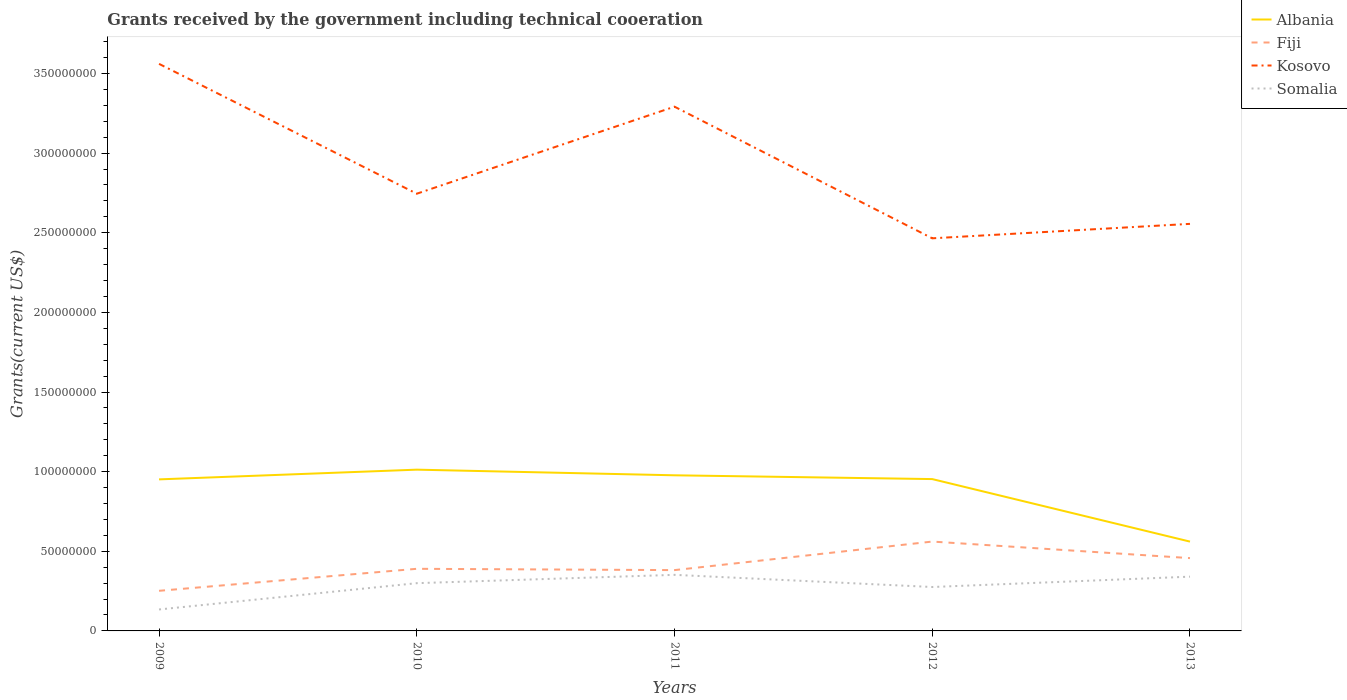How many different coloured lines are there?
Make the answer very short. 4. Is the number of lines equal to the number of legend labels?
Provide a short and direct response. Yes. Across all years, what is the maximum total grants received by the government in Kosovo?
Give a very brief answer. 2.46e+08. What is the total total grants received by the government in Albania in the graph?
Make the answer very short. -1.80e+05. What is the difference between the highest and the second highest total grants received by the government in Kosovo?
Provide a succinct answer. 1.10e+08. What is the difference between the highest and the lowest total grants received by the government in Somalia?
Keep it short and to the point. 3. What is the difference between two consecutive major ticks on the Y-axis?
Offer a terse response. 5.00e+07. Are the values on the major ticks of Y-axis written in scientific E-notation?
Offer a terse response. No. Does the graph contain any zero values?
Provide a short and direct response. No. How are the legend labels stacked?
Provide a succinct answer. Vertical. What is the title of the graph?
Provide a succinct answer. Grants received by the government including technical cooeration. What is the label or title of the X-axis?
Offer a terse response. Years. What is the label or title of the Y-axis?
Keep it short and to the point. Grants(current US$). What is the Grants(current US$) of Albania in 2009?
Offer a very short reply. 9.52e+07. What is the Grants(current US$) of Fiji in 2009?
Give a very brief answer. 2.52e+07. What is the Grants(current US$) in Kosovo in 2009?
Ensure brevity in your answer.  3.56e+08. What is the Grants(current US$) of Somalia in 2009?
Keep it short and to the point. 1.35e+07. What is the Grants(current US$) of Albania in 2010?
Keep it short and to the point. 1.01e+08. What is the Grants(current US$) of Fiji in 2010?
Offer a terse response. 3.90e+07. What is the Grants(current US$) of Kosovo in 2010?
Keep it short and to the point. 2.74e+08. What is the Grants(current US$) of Somalia in 2010?
Provide a succinct answer. 3.00e+07. What is the Grants(current US$) of Albania in 2011?
Your response must be concise. 9.77e+07. What is the Grants(current US$) of Fiji in 2011?
Your answer should be compact. 3.82e+07. What is the Grants(current US$) in Kosovo in 2011?
Offer a very short reply. 3.29e+08. What is the Grants(current US$) of Somalia in 2011?
Offer a very short reply. 3.52e+07. What is the Grants(current US$) in Albania in 2012?
Offer a very short reply. 9.53e+07. What is the Grants(current US$) in Fiji in 2012?
Give a very brief answer. 5.61e+07. What is the Grants(current US$) of Kosovo in 2012?
Give a very brief answer. 2.46e+08. What is the Grants(current US$) in Somalia in 2012?
Give a very brief answer. 2.76e+07. What is the Grants(current US$) in Albania in 2013?
Give a very brief answer. 5.61e+07. What is the Grants(current US$) in Fiji in 2013?
Offer a very short reply. 4.57e+07. What is the Grants(current US$) of Kosovo in 2013?
Your answer should be compact. 2.56e+08. What is the Grants(current US$) in Somalia in 2013?
Your response must be concise. 3.41e+07. Across all years, what is the maximum Grants(current US$) in Albania?
Make the answer very short. 1.01e+08. Across all years, what is the maximum Grants(current US$) in Fiji?
Offer a very short reply. 5.61e+07. Across all years, what is the maximum Grants(current US$) of Kosovo?
Give a very brief answer. 3.56e+08. Across all years, what is the maximum Grants(current US$) of Somalia?
Your answer should be very brief. 3.52e+07. Across all years, what is the minimum Grants(current US$) in Albania?
Provide a succinct answer. 5.61e+07. Across all years, what is the minimum Grants(current US$) in Fiji?
Provide a short and direct response. 2.52e+07. Across all years, what is the minimum Grants(current US$) of Kosovo?
Keep it short and to the point. 2.46e+08. Across all years, what is the minimum Grants(current US$) in Somalia?
Your response must be concise. 1.35e+07. What is the total Grants(current US$) in Albania in the graph?
Your answer should be very brief. 4.46e+08. What is the total Grants(current US$) of Fiji in the graph?
Give a very brief answer. 2.04e+08. What is the total Grants(current US$) of Kosovo in the graph?
Provide a succinct answer. 1.46e+09. What is the total Grants(current US$) of Somalia in the graph?
Give a very brief answer. 1.40e+08. What is the difference between the Grants(current US$) of Albania in 2009 and that in 2010?
Provide a succinct answer. -6.10e+06. What is the difference between the Grants(current US$) in Fiji in 2009 and that in 2010?
Offer a very short reply. -1.38e+07. What is the difference between the Grants(current US$) in Kosovo in 2009 and that in 2010?
Provide a succinct answer. 8.15e+07. What is the difference between the Grants(current US$) of Somalia in 2009 and that in 2010?
Keep it short and to the point. -1.65e+07. What is the difference between the Grants(current US$) of Albania in 2009 and that in 2011?
Your response must be concise. -2.56e+06. What is the difference between the Grants(current US$) in Fiji in 2009 and that in 2011?
Your response must be concise. -1.30e+07. What is the difference between the Grants(current US$) in Kosovo in 2009 and that in 2011?
Provide a succinct answer. 2.69e+07. What is the difference between the Grants(current US$) in Somalia in 2009 and that in 2011?
Offer a very short reply. -2.17e+07. What is the difference between the Grants(current US$) of Albania in 2009 and that in 2012?
Make the answer very short. -1.80e+05. What is the difference between the Grants(current US$) of Fiji in 2009 and that in 2012?
Provide a short and direct response. -3.09e+07. What is the difference between the Grants(current US$) in Kosovo in 2009 and that in 2012?
Provide a short and direct response. 1.10e+08. What is the difference between the Grants(current US$) of Somalia in 2009 and that in 2012?
Provide a short and direct response. -1.41e+07. What is the difference between the Grants(current US$) of Albania in 2009 and that in 2013?
Your response must be concise. 3.91e+07. What is the difference between the Grants(current US$) of Fiji in 2009 and that in 2013?
Provide a succinct answer. -2.05e+07. What is the difference between the Grants(current US$) in Kosovo in 2009 and that in 2013?
Offer a terse response. 1.00e+08. What is the difference between the Grants(current US$) of Somalia in 2009 and that in 2013?
Keep it short and to the point. -2.06e+07. What is the difference between the Grants(current US$) in Albania in 2010 and that in 2011?
Make the answer very short. 3.54e+06. What is the difference between the Grants(current US$) of Fiji in 2010 and that in 2011?
Your answer should be compact. 8.20e+05. What is the difference between the Grants(current US$) of Kosovo in 2010 and that in 2011?
Provide a succinct answer. -5.46e+07. What is the difference between the Grants(current US$) of Somalia in 2010 and that in 2011?
Your response must be concise. -5.23e+06. What is the difference between the Grants(current US$) of Albania in 2010 and that in 2012?
Your response must be concise. 5.92e+06. What is the difference between the Grants(current US$) in Fiji in 2010 and that in 2012?
Your answer should be compact. -1.71e+07. What is the difference between the Grants(current US$) of Kosovo in 2010 and that in 2012?
Make the answer very short. 2.80e+07. What is the difference between the Grants(current US$) in Somalia in 2010 and that in 2012?
Provide a short and direct response. 2.41e+06. What is the difference between the Grants(current US$) of Albania in 2010 and that in 2013?
Keep it short and to the point. 4.52e+07. What is the difference between the Grants(current US$) of Fiji in 2010 and that in 2013?
Your answer should be very brief. -6.71e+06. What is the difference between the Grants(current US$) of Kosovo in 2010 and that in 2013?
Make the answer very short. 1.89e+07. What is the difference between the Grants(current US$) of Somalia in 2010 and that in 2013?
Keep it short and to the point. -4.09e+06. What is the difference between the Grants(current US$) of Albania in 2011 and that in 2012?
Your response must be concise. 2.38e+06. What is the difference between the Grants(current US$) in Fiji in 2011 and that in 2012?
Keep it short and to the point. -1.79e+07. What is the difference between the Grants(current US$) in Kosovo in 2011 and that in 2012?
Provide a short and direct response. 8.26e+07. What is the difference between the Grants(current US$) in Somalia in 2011 and that in 2012?
Keep it short and to the point. 7.64e+06. What is the difference between the Grants(current US$) in Albania in 2011 and that in 2013?
Provide a short and direct response. 4.16e+07. What is the difference between the Grants(current US$) in Fiji in 2011 and that in 2013?
Provide a short and direct response. -7.53e+06. What is the difference between the Grants(current US$) of Kosovo in 2011 and that in 2013?
Your answer should be compact. 7.36e+07. What is the difference between the Grants(current US$) in Somalia in 2011 and that in 2013?
Provide a succinct answer. 1.14e+06. What is the difference between the Grants(current US$) in Albania in 2012 and that in 2013?
Make the answer very short. 3.92e+07. What is the difference between the Grants(current US$) in Fiji in 2012 and that in 2013?
Provide a succinct answer. 1.04e+07. What is the difference between the Grants(current US$) of Kosovo in 2012 and that in 2013?
Provide a short and direct response. -9.07e+06. What is the difference between the Grants(current US$) of Somalia in 2012 and that in 2013?
Keep it short and to the point. -6.50e+06. What is the difference between the Grants(current US$) in Albania in 2009 and the Grants(current US$) in Fiji in 2010?
Your response must be concise. 5.62e+07. What is the difference between the Grants(current US$) of Albania in 2009 and the Grants(current US$) of Kosovo in 2010?
Provide a succinct answer. -1.79e+08. What is the difference between the Grants(current US$) in Albania in 2009 and the Grants(current US$) in Somalia in 2010?
Your response must be concise. 6.52e+07. What is the difference between the Grants(current US$) in Fiji in 2009 and the Grants(current US$) in Kosovo in 2010?
Your answer should be very brief. -2.49e+08. What is the difference between the Grants(current US$) in Fiji in 2009 and the Grants(current US$) in Somalia in 2010?
Provide a succinct answer. -4.80e+06. What is the difference between the Grants(current US$) in Kosovo in 2009 and the Grants(current US$) in Somalia in 2010?
Offer a very short reply. 3.26e+08. What is the difference between the Grants(current US$) in Albania in 2009 and the Grants(current US$) in Fiji in 2011?
Make the answer very short. 5.70e+07. What is the difference between the Grants(current US$) of Albania in 2009 and the Grants(current US$) of Kosovo in 2011?
Make the answer very short. -2.34e+08. What is the difference between the Grants(current US$) of Albania in 2009 and the Grants(current US$) of Somalia in 2011?
Your answer should be compact. 5.99e+07. What is the difference between the Grants(current US$) of Fiji in 2009 and the Grants(current US$) of Kosovo in 2011?
Your answer should be compact. -3.04e+08. What is the difference between the Grants(current US$) in Fiji in 2009 and the Grants(current US$) in Somalia in 2011?
Provide a short and direct response. -1.00e+07. What is the difference between the Grants(current US$) in Kosovo in 2009 and the Grants(current US$) in Somalia in 2011?
Your answer should be compact. 3.21e+08. What is the difference between the Grants(current US$) of Albania in 2009 and the Grants(current US$) of Fiji in 2012?
Your answer should be compact. 3.90e+07. What is the difference between the Grants(current US$) in Albania in 2009 and the Grants(current US$) in Kosovo in 2012?
Offer a very short reply. -1.51e+08. What is the difference between the Grants(current US$) of Albania in 2009 and the Grants(current US$) of Somalia in 2012?
Provide a short and direct response. 6.76e+07. What is the difference between the Grants(current US$) in Fiji in 2009 and the Grants(current US$) in Kosovo in 2012?
Provide a short and direct response. -2.21e+08. What is the difference between the Grants(current US$) of Fiji in 2009 and the Grants(current US$) of Somalia in 2012?
Your response must be concise. -2.39e+06. What is the difference between the Grants(current US$) of Kosovo in 2009 and the Grants(current US$) of Somalia in 2012?
Offer a terse response. 3.28e+08. What is the difference between the Grants(current US$) in Albania in 2009 and the Grants(current US$) in Fiji in 2013?
Offer a very short reply. 4.94e+07. What is the difference between the Grants(current US$) of Albania in 2009 and the Grants(current US$) of Kosovo in 2013?
Your answer should be compact. -1.60e+08. What is the difference between the Grants(current US$) in Albania in 2009 and the Grants(current US$) in Somalia in 2013?
Provide a short and direct response. 6.11e+07. What is the difference between the Grants(current US$) of Fiji in 2009 and the Grants(current US$) of Kosovo in 2013?
Ensure brevity in your answer.  -2.30e+08. What is the difference between the Grants(current US$) of Fiji in 2009 and the Grants(current US$) of Somalia in 2013?
Offer a terse response. -8.89e+06. What is the difference between the Grants(current US$) of Kosovo in 2009 and the Grants(current US$) of Somalia in 2013?
Offer a terse response. 3.22e+08. What is the difference between the Grants(current US$) in Albania in 2010 and the Grants(current US$) in Fiji in 2011?
Provide a succinct answer. 6.31e+07. What is the difference between the Grants(current US$) in Albania in 2010 and the Grants(current US$) in Kosovo in 2011?
Provide a succinct answer. -2.28e+08. What is the difference between the Grants(current US$) of Albania in 2010 and the Grants(current US$) of Somalia in 2011?
Provide a short and direct response. 6.60e+07. What is the difference between the Grants(current US$) in Fiji in 2010 and the Grants(current US$) in Kosovo in 2011?
Keep it short and to the point. -2.90e+08. What is the difference between the Grants(current US$) in Fiji in 2010 and the Grants(current US$) in Somalia in 2011?
Provide a succinct answer. 3.79e+06. What is the difference between the Grants(current US$) in Kosovo in 2010 and the Grants(current US$) in Somalia in 2011?
Keep it short and to the point. 2.39e+08. What is the difference between the Grants(current US$) of Albania in 2010 and the Grants(current US$) of Fiji in 2012?
Offer a terse response. 4.52e+07. What is the difference between the Grants(current US$) in Albania in 2010 and the Grants(current US$) in Kosovo in 2012?
Your response must be concise. -1.45e+08. What is the difference between the Grants(current US$) of Albania in 2010 and the Grants(current US$) of Somalia in 2012?
Offer a terse response. 7.37e+07. What is the difference between the Grants(current US$) of Fiji in 2010 and the Grants(current US$) of Kosovo in 2012?
Your response must be concise. -2.08e+08. What is the difference between the Grants(current US$) in Fiji in 2010 and the Grants(current US$) in Somalia in 2012?
Your answer should be compact. 1.14e+07. What is the difference between the Grants(current US$) of Kosovo in 2010 and the Grants(current US$) of Somalia in 2012?
Offer a very short reply. 2.47e+08. What is the difference between the Grants(current US$) in Albania in 2010 and the Grants(current US$) in Fiji in 2013?
Your response must be concise. 5.55e+07. What is the difference between the Grants(current US$) of Albania in 2010 and the Grants(current US$) of Kosovo in 2013?
Offer a terse response. -1.54e+08. What is the difference between the Grants(current US$) of Albania in 2010 and the Grants(current US$) of Somalia in 2013?
Make the answer very short. 6.72e+07. What is the difference between the Grants(current US$) in Fiji in 2010 and the Grants(current US$) in Kosovo in 2013?
Your answer should be very brief. -2.17e+08. What is the difference between the Grants(current US$) of Fiji in 2010 and the Grants(current US$) of Somalia in 2013?
Your answer should be very brief. 4.93e+06. What is the difference between the Grants(current US$) of Kosovo in 2010 and the Grants(current US$) of Somalia in 2013?
Your answer should be compact. 2.40e+08. What is the difference between the Grants(current US$) of Albania in 2011 and the Grants(current US$) of Fiji in 2012?
Ensure brevity in your answer.  4.16e+07. What is the difference between the Grants(current US$) of Albania in 2011 and the Grants(current US$) of Kosovo in 2012?
Make the answer very short. -1.49e+08. What is the difference between the Grants(current US$) in Albania in 2011 and the Grants(current US$) in Somalia in 2012?
Ensure brevity in your answer.  7.01e+07. What is the difference between the Grants(current US$) of Fiji in 2011 and the Grants(current US$) of Kosovo in 2012?
Make the answer very short. -2.08e+08. What is the difference between the Grants(current US$) in Fiji in 2011 and the Grants(current US$) in Somalia in 2012?
Your answer should be compact. 1.06e+07. What is the difference between the Grants(current US$) of Kosovo in 2011 and the Grants(current US$) of Somalia in 2012?
Keep it short and to the point. 3.02e+08. What is the difference between the Grants(current US$) in Albania in 2011 and the Grants(current US$) in Fiji in 2013?
Provide a succinct answer. 5.20e+07. What is the difference between the Grants(current US$) of Albania in 2011 and the Grants(current US$) of Kosovo in 2013?
Make the answer very short. -1.58e+08. What is the difference between the Grants(current US$) in Albania in 2011 and the Grants(current US$) in Somalia in 2013?
Make the answer very short. 6.36e+07. What is the difference between the Grants(current US$) of Fiji in 2011 and the Grants(current US$) of Kosovo in 2013?
Keep it short and to the point. -2.17e+08. What is the difference between the Grants(current US$) of Fiji in 2011 and the Grants(current US$) of Somalia in 2013?
Offer a terse response. 4.11e+06. What is the difference between the Grants(current US$) of Kosovo in 2011 and the Grants(current US$) of Somalia in 2013?
Offer a very short reply. 2.95e+08. What is the difference between the Grants(current US$) of Albania in 2012 and the Grants(current US$) of Fiji in 2013?
Provide a succinct answer. 4.96e+07. What is the difference between the Grants(current US$) of Albania in 2012 and the Grants(current US$) of Kosovo in 2013?
Provide a succinct answer. -1.60e+08. What is the difference between the Grants(current US$) of Albania in 2012 and the Grants(current US$) of Somalia in 2013?
Your answer should be very brief. 6.13e+07. What is the difference between the Grants(current US$) in Fiji in 2012 and the Grants(current US$) in Kosovo in 2013?
Your response must be concise. -1.99e+08. What is the difference between the Grants(current US$) of Fiji in 2012 and the Grants(current US$) of Somalia in 2013?
Give a very brief answer. 2.20e+07. What is the difference between the Grants(current US$) in Kosovo in 2012 and the Grants(current US$) in Somalia in 2013?
Your response must be concise. 2.12e+08. What is the average Grants(current US$) of Albania per year?
Your response must be concise. 8.91e+07. What is the average Grants(current US$) in Fiji per year?
Offer a very short reply. 4.08e+07. What is the average Grants(current US$) of Kosovo per year?
Offer a very short reply. 2.92e+08. What is the average Grants(current US$) of Somalia per year?
Make the answer very short. 2.81e+07. In the year 2009, what is the difference between the Grants(current US$) in Albania and Grants(current US$) in Fiji?
Offer a terse response. 7.00e+07. In the year 2009, what is the difference between the Grants(current US$) in Albania and Grants(current US$) in Kosovo?
Make the answer very short. -2.61e+08. In the year 2009, what is the difference between the Grants(current US$) in Albania and Grants(current US$) in Somalia?
Provide a short and direct response. 8.17e+07. In the year 2009, what is the difference between the Grants(current US$) of Fiji and Grants(current US$) of Kosovo?
Make the answer very short. -3.31e+08. In the year 2009, what is the difference between the Grants(current US$) of Fiji and Grants(current US$) of Somalia?
Provide a succinct answer. 1.17e+07. In the year 2009, what is the difference between the Grants(current US$) of Kosovo and Grants(current US$) of Somalia?
Offer a terse response. 3.43e+08. In the year 2010, what is the difference between the Grants(current US$) of Albania and Grants(current US$) of Fiji?
Keep it short and to the point. 6.22e+07. In the year 2010, what is the difference between the Grants(current US$) of Albania and Grants(current US$) of Kosovo?
Offer a very short reply. -1.73e+08. In the year 2010, what is the difference between the Grants(current US$) in Albania and Grants(current US$) in Somalia?
Your response must be concise. 7.13e+07. In the year 2010, what is the difference between the Grants(current US$) of Fiji and Grants(current US$) of Kosovo?
Offer a very short reply. -2.36e+08. In the year 2010, what is the difference between the Grants(current US$) in Fiji and Grants(current US$) in Somalia?
Your answer should be very brief. 9.02e+06. In the year 2010, what is the difference between the Grants(current US$) of Kosovo and Grants(current US$) of Somalia?
Give a very brief answer. 2.45e+08. In the year 2011, what is the difference between the Grants(current US$) of Albania and Grants(current US$) of Fiji?
Your answer should be very brief. 5.95e+07. In the year 2011, what is the difference between the Grants(current US$) in Albania and Grants(current US$) in Kosovo?
Your answer should be very brief. -2.31e+08. In the year 2011, what is the difference between the Grants(current US$) in Albania and Grants(current US$) in Somalia?
Give a very brief answer. 6.25e+07. In the year 2011, what is the difference between the Grants(current US$) of Fiji and Grants(current US$) of Kosovo?
Your answer should be very brief. -2.91e+08. In the year 2011, what is the difference between the Grants(current US$) in Fiji and Grants(current US$) in Somalia?
Ensure brevity in your answer.  2.97e+06. In the year 2011, what is the difference between the Grants(current US$) of Kosovo and Grants(current US$) of Somalia?
Your response must be concise. 2.94e+08. In the year 2012, what is the difference between the Grants(current US$) in Albania and Grants(current US$) in Fiji?
Ensure brevity in your answer.  3.92e+07. In the year 2012, what is the difference between the Grants(current US$) of Albania and Grants(current US$) of Kosovo?
Your answer should be very brief. -1.51e+08. In the year 2012, what is the difference between the Grants(current US$) in Albania and Grants(current US$) in Somalia?
Make the answer very short. 6.78e+07. In the year 2012, what is the difference between the Grants(current US$) in Fiji and Grants(current US$) in Kosovo?
Offer a very short reply. -1.90e+08. In the year 2012, what is the difference between the Grants(current US$) in Fiji and Grants(current US$) in Somalia?
Offer a very short reply. 2.85e+07. In the year 2012, what is the difference between the Grants(current US$) of Kosovo and Grants(current US$) of Somalia?
Provide a short and direct response. 2.19e+08. In the year 2013, what is the difference between the Grants(current US$) in Albania and Grants(current US$) in Fiji?
Provide a short and direct response. 1.04e+07. In the year 2013, what is the difference between the Grants(current US$) of Albania and Grants(current US$) of Kosovo?
Your answer should be very brief. -1.99e+08. In the year 2013, what is the difference between the Grants(current US$) of Albania and Grants(current US$) of Somalia?
Your answer should be very brief. 2.20e+07. In the year 2013, what is the difference between the Grants(current US$) in Fiji and Grants(current US$) in Kosovo?
Ensure brevity in your answer.  -2.10e+08. In the year 2013, what is the difference between the Grants(current US$) of Fiji and Grants(current US$) of Somalia?
Make the answer very short. 1.16e+07. In the year 2013, what is the difference between the Grants(current US$) of Kosovo and Grants(current US$) of Somalia?
Offer a very short reply. 2.22e+08. What is the ratio of the Grants(current US$) of Albania in 2009 to that in 2010?
Provide a succinct answer. 0.94. What is the ratio of the Grants(current US$) in Fiji in 2009 to that in 2010?
Make the answer very short. 0.65. What is the ratio of the Grants(current US$) of Kosovo in 2009 to that in 2010?
Offer a terse response. 1.3. What is the ratio of the Grants(current US$) of Somalia in 2009 to that in 2010?
Your answer should be very brief. 0.45. What is the ratio of the Grants(current US$) in Albania in 2009 to that in 2011?
Keep it short and to the point. 0.97. What is the ratio of the Grants(current US$) in Fiji in 2009 to that in 2011?
Give a very brief answer. 0.66. What is the ratio of the Grants(current US$) of Kosovo in 2009 to that in 2011?
Keep it short and to the point. 1.08. What is the ratio of the Grants(current US$) in Somalia in 2009 to that in 2011?
Ensure brevity in your answer.  0.38. What is the ratio of the Grants(current US$) in Albania in 2009 to that in 2012?
Your answer should be very brief. 1. What is the ratio of the Grants(current US$) in Fiji in 2009 to that in 2012?
Give a very brief answer. 0.45. What is the ratio of the Grants(current US$) in Kosovo in 2009 to that in 2012?
Ensure brevity in your answer.  1.44. What is the ratio of the Grants(current US$) of Somalia in 2009 to that in 2012?
Provide a short and direct response. 0.49. What is the ratio of the Grants(current US$) in Albania in 2009 to that in 2013?
Your response must be concise. 1.7. What is the ratio of the Grants(current US$) in Fiji in 2009 to that in 2013?
Your answer should be compact. 0.55. What is the ratio of the Grants(current US$) in Kosovo in 2009 to that in 2013?
Give a very brief answer. 1.39. What is the ratio of the Grants(current US$) of Somalia in 2009 to that in 2013?
Ensure brevity in your answer.  0.4. What is the ratio of the Grants(current US$) in Albania in 2010 to that in 2011?
Provide a succinct answer. 1.04. What is the ratio of the Grants(current US$) of Fiji in 2010 to that in 2011?
Offer a very short reply. 1.02. What is the ratio of the Grants(current US$) in Kosovo in 2010 to that in 2011?
Keep it short and to the point. 0.83. What is the ratio of the Grants(current US$) in Somalia in 2010 to that in 2011?
Offer a terse response. 0.85. What is the ratio of the Grants(current US$) in Albania in 2010 to that in 2012?
Your answer should be compact. 1.06. What is the ratio of the Grants(current US$) of Fiji in 2010 to that in 2012?
Keep it short and to the point. 0.7. What is the ratio of the Grants(current US$) in Kosovo in 2010 to that in 2012?
Provide a succinct answer. 1.11. What is the ratio of the Grants(current US$) of Somalia in 2010 to that in 2012?
Ensure brevity in your answer.  1.09. What is the ratio of the Grants(current US$) in Albania in 2010 to that in 2013?
Provide a succinct answer. 1.81. What is the ratio of the Grants(current US$) of Fiji in 2010 to that in 2013?
Your answer should be compact. 0.85. What is the ratio of the Grants(current US$) of Kosovo in 2010 to that in 2013?
Offer a terse response. 1.07. What is the ratio of the Grants(current US$) in Fiji in 2011 to that in 2012?
Make the answer very short. 0.68. What is the ratio of the Grants(current US$) of Kosovo in 2011 to that in 2012?
Provide a short and direct response. 1.34. What is the ratio of the Grants(current US$) in Somalia in 2011 to that in 2012?
Offer a terse response. 1.28. What is the ratio of the Grants(current US$) in Albania in 2011 to that in 2013?
Make the answer very short. 1.74. What is the ratio of the Grants(current US$) of Fiji in 2011 to that in 2013?
Provide a short and direct response. 0.84. What is the ratio of the Grants(current US$) in Kosovo in 2011 to that in 2013?
Provide a succinct answer. 1.29. What is the ratio of the Grants(current US$) of Somalia in 2011 to that in 2013?
Your response must be concise. 1.03. What is the ratio of the Grants(current US$) of Albania in 2012 to that in 2013?
Provide a succinct answer. 1.7. What is the ratio of the Grants(current US$) of Fiji in 2012 to that in 2013?
Offer a terse response. 1.23. What is the ratio of the Grants(current US$) in Kosovo in 2012 to that in 2013?
Your answer should be very brief. 0.96. What is the ratio of the Grants(current US$) of Somalia in 2012 to that in 2013?
Provide a short and direct response. 0.81. What is the difference between the highest and the second highest Grants(current US$) in Albania?
Give a very brief answer. 3.54e+06. What is the difference between the highest and the second highest Grants(current US$) of Fiji?
Ensure brevity in your answer.  1.04e+07. What is the difference between the highest and the second highest Grants(current US$) in Kosovo?
Make the answer very short. 2.69e+07. What is the difference between the highest and the second highest Grants(current US$) in Somalia?
Offer a very short reply. 1.14e+06. What is the difference between the highest and the lowest Grants(current US$) in Albania?
Offer a very short reply. 4.52e+07. What is the difference between the highest and the lowest Grants(current US$) of Fiji?
Ensure brevity in your answer.  3.09e+07. What is the difference between the highest and the lowest Grants(current US$) in Kosovo?
Ensure brevity in your answer.  1.10e+08. What is the difference between the highest and the lowest Grants(current US$) in Somalia?
Your answer should be compact. 2.17e+07. 